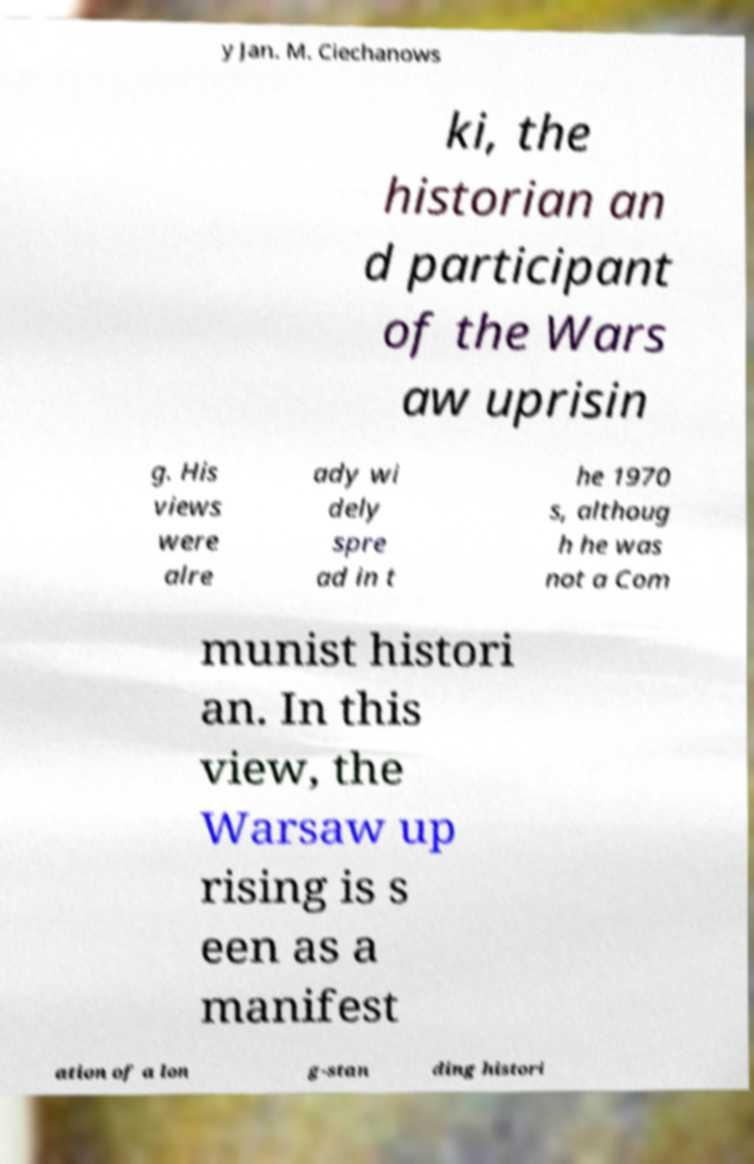I need the written content from this picture converted into text. Can you do that? y Jan. M. Ciechanows ki, the historian an d participant of the Wars aw uprisin g. His views were alre ady wi dely spre ad in t he 1970 s, althoug h he was not a Com munist histori an. In this view, the Warsaw up rising is s een as a manifest ation of a lon g-stan ding histori 